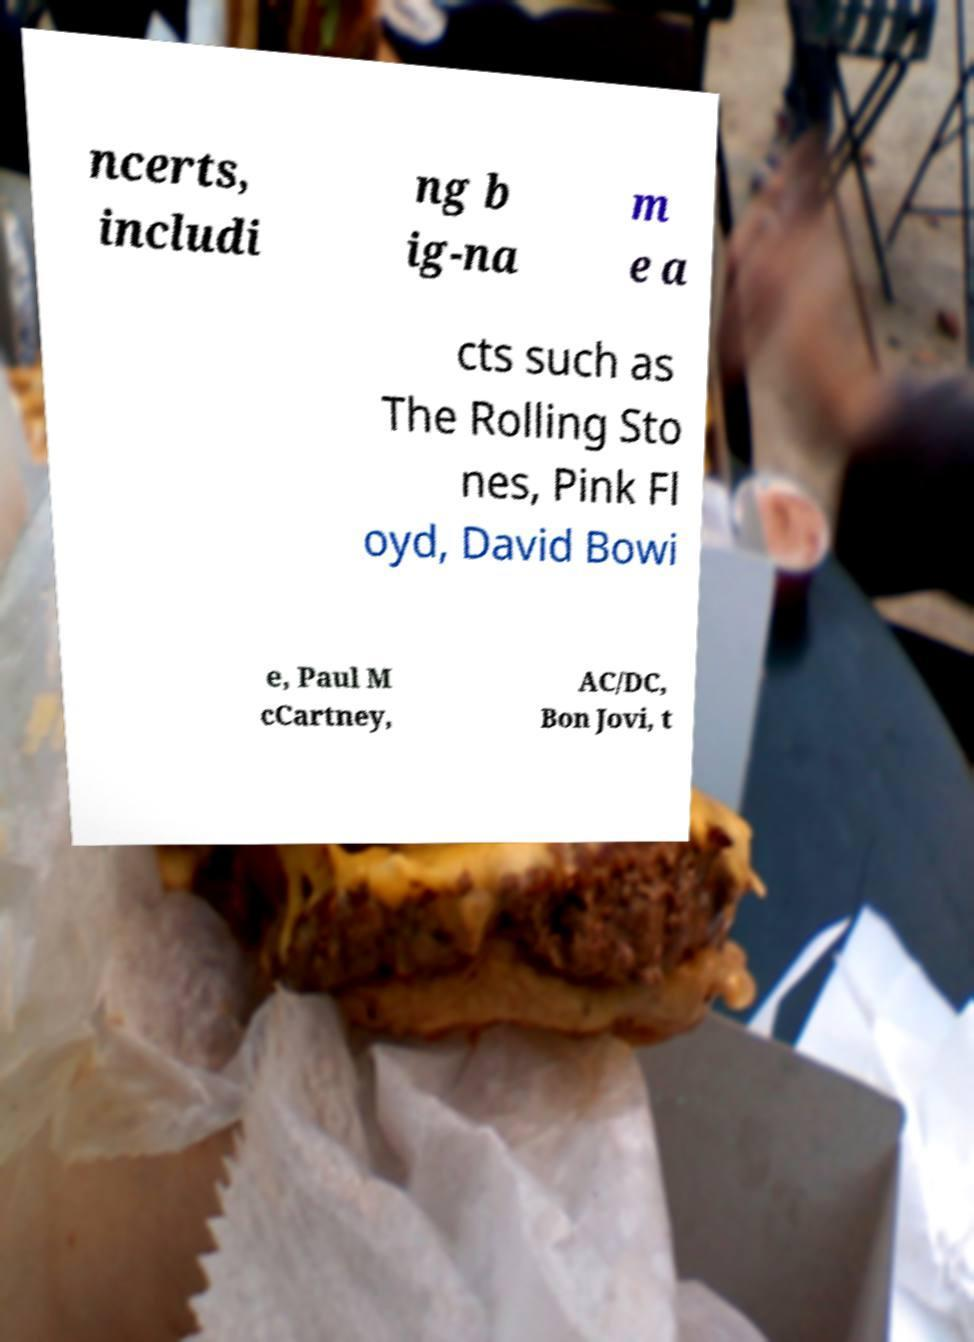Please identify and transcribe the text found in this image. ncerts, includi ng b ig-na m e a cts such as The Rolling Sto nes, Pink Fl oyd, David Bowi e, Paul M cCartney, AC/DC, Bon Jovi, t 